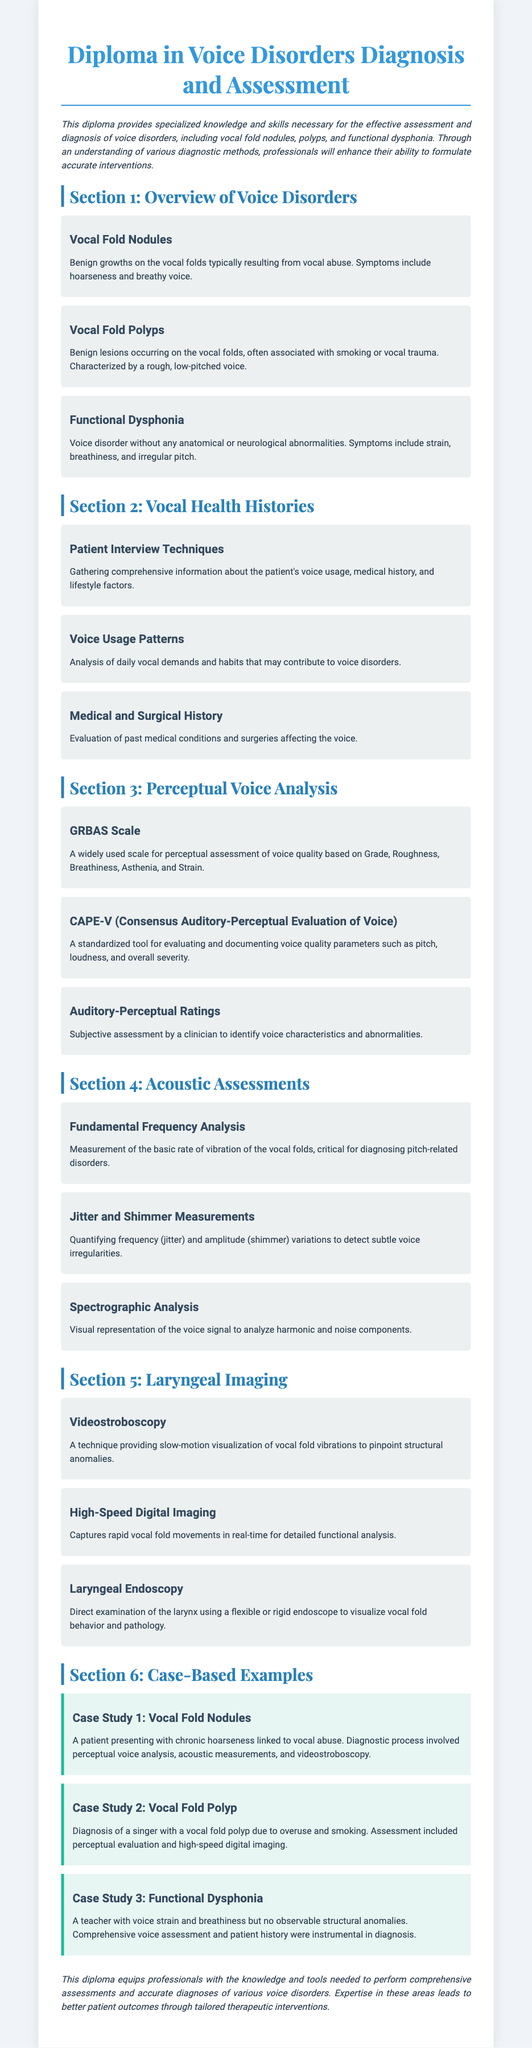What are vocal fold nodules? Vocal fold nodules are benign growths on the vocal folds typically resulting from vocal abuse.
Answer: benign growths What assessment tool evaluates voice quality parameters? The document mentions a standardized tool for evaluating voice quality parameters is CAPE-V.
Answer: CAPE-V What is the primary symptom of functional dysphonia? The symptoms of functional dysphonia include strain, breathiness, and irregular pitch.
Answer: strain What diagnostic technique provides slow-motion visualization of vocal fold vibrations? Videostroboscopy is a technique that provides slow-motion visualization of vocal fold vibrations.
Answer: Videostroboscopy How many case studies are presented in the document? The document presents three case studies related to voice disorders.
Answer: three What does the GRBAS scale assess? The GRBAS scale is used for perceptual assessment of voice quality based on Grade, Roughness, Breathiness, Asthenia, and Strain.
Answer: voice quality What can be analyzed in vocal health histories? Vocal health histories include gathering comprehensive information about the patient's voice usage, medical history, and lifestyle factors.
Answer: voice usage Which disorder is linked to vocal overuse and smoking? Vocal fold polyp is often associated with overuse and smoking.
Answer: Vocal fold polyp What role does spectrographic analysis serve? Spectrographic analysis provides a visual representation of the voice signal to analyze harmonic and noise components.
Answer: visual representation 